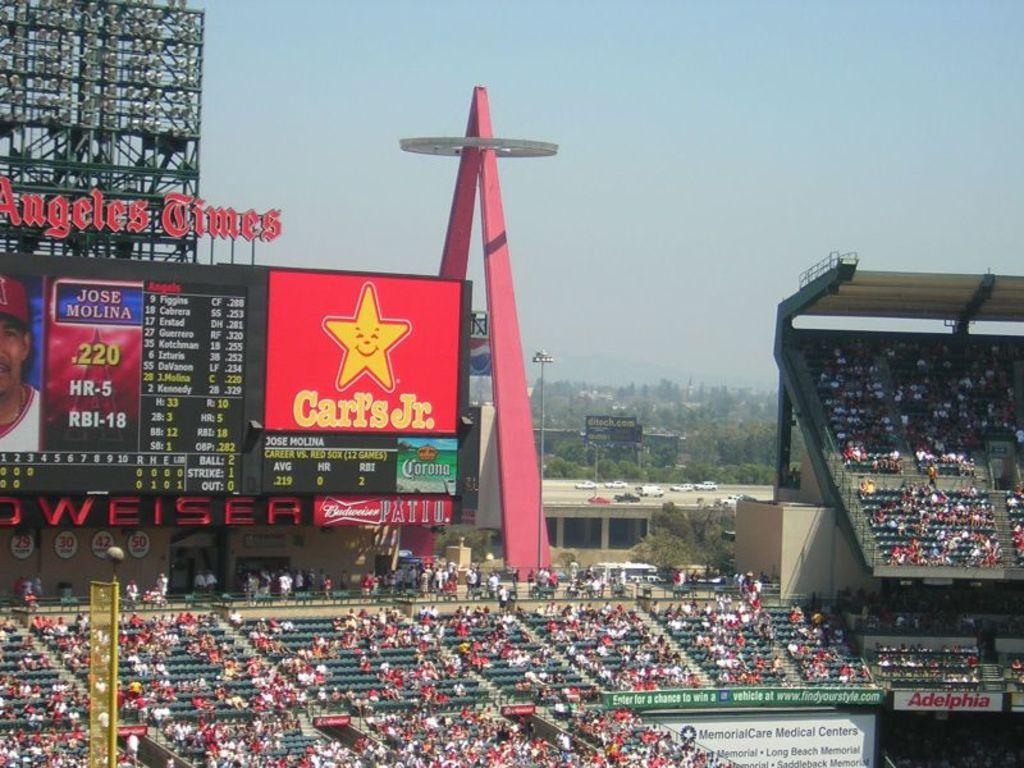<image>
Write a terse but informative summary of the picture. A large ad for Carl's Jr. hangs over a sports stadium with fans wearing red. 